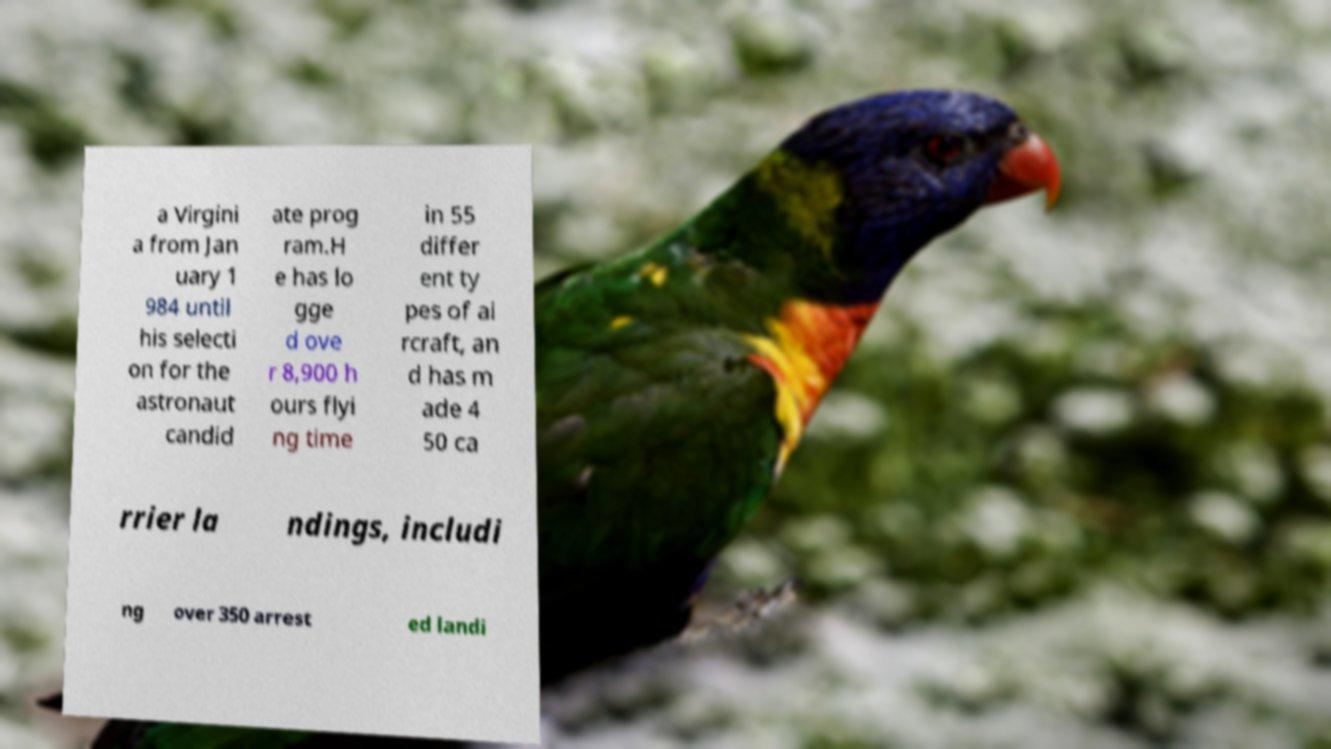I need the written content from this picture converted into text. Can you do that? a Virgini a from Jan uary 1 984 until his selecti on for the astronaut candid ate prog ram.H e has lo gge d ove r 8,900 h ours flyi ng time in 55 differ ent ty pes of ai rcraft, an d has m ade 4 50 ca rrier la ndings, includi ng over 350 arrest ed landi 